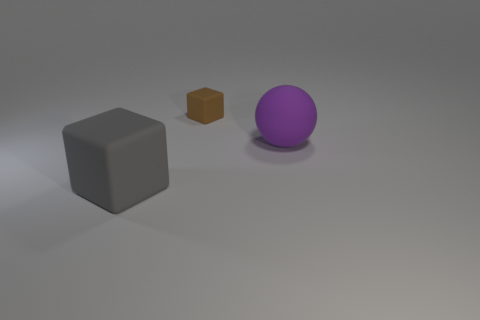Add 2 big gray blocks. How many objects exist? 5 Subtract 0 yellow cubes. How many objects are left? 3 Subtract all blocks. How many objects are left? 1 Subtract all gray things. Subtract all large cubes. How many objects are left? 1 Add 2 large gray matte things. How many large gray matte things are left? 3 Add 1 big purple matte things. How many big purple matte things exist? 2 